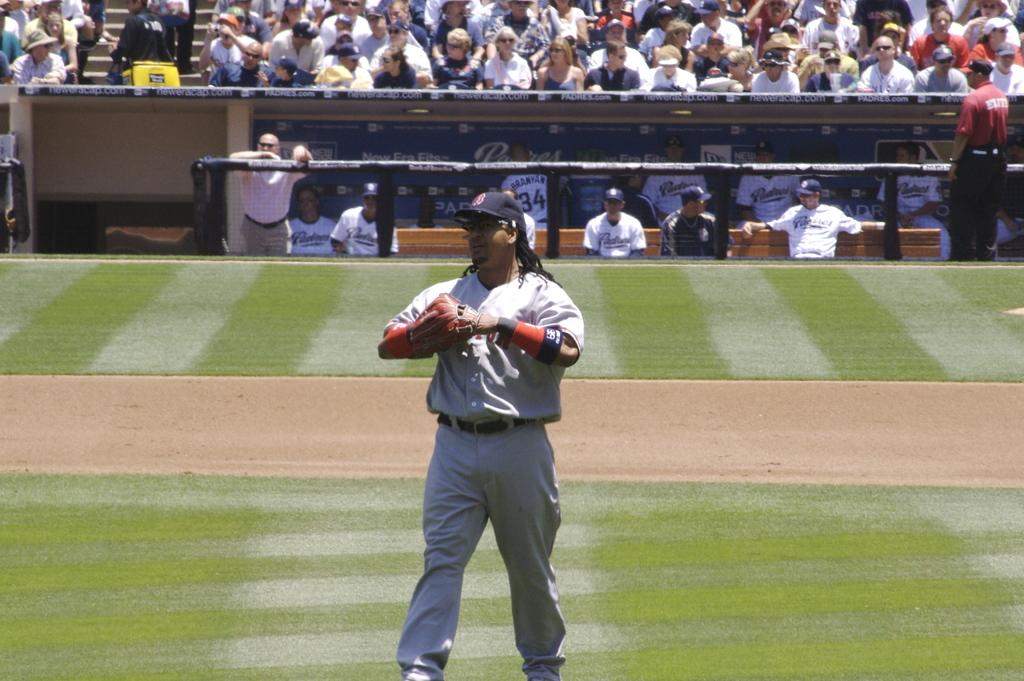What is the main subject in the center of the image? There is a man standing in the center of the image. What is the man wearing on his head? The man is wearing a cap. What can be seen in the background of the image? There is a crowd sitting in the background, and there are people visible in the background. What object is present in the image? There is a board present. What type of thread is being used to sew the roof in the image? There is no roof or thread present in the image. What is the name of the downtown area visible in the image? The image does not depict a downtown area, and therefore no specific location can be identified. 